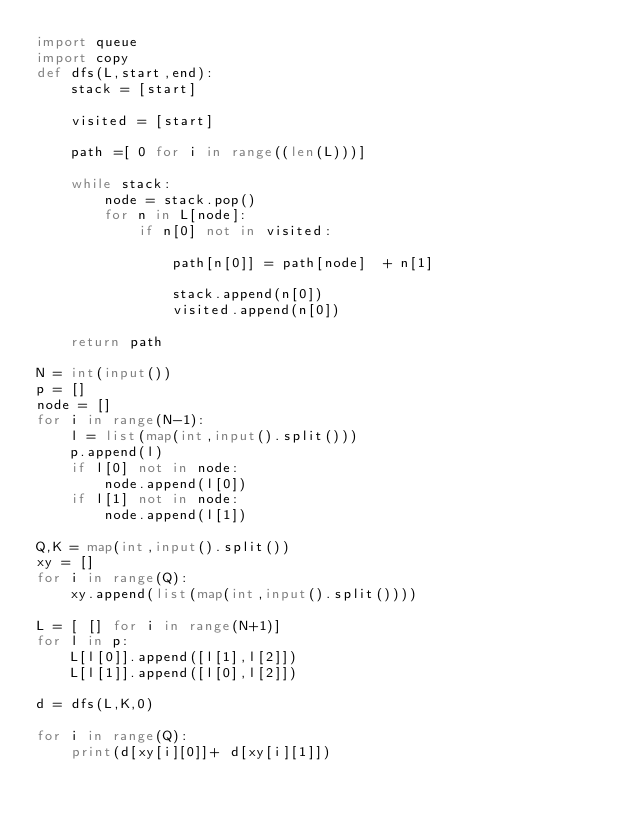Convert code to text. <code><loc_0><loc_0><loc_500><loc_500><_Python_>import queue
import copy
def dfs(L,start,end):
    stack = [start]

    visited = [start]

    path =[ 0 for i in range((len(L)))]

    while stack:
        node = stack.pop()
        for n in L[node]:
            if n[0] not in visited:

                path[n[0]] = path[node]  + n[1]

                stack.append(n[0])
                visited.append(n[0])

    return path

N = int(input())
p = []
node = []
for i in range(N-1):
    l = list(map(int,input().split()))
    p.append(l)
    if l[0] not in node:
        node.append(l[0])
    if l[1] not in node:
        node.append(l[1])

Q,K = map(int,input().split())
xy = []
for i in range(Q):
    xy.append(list(map(int,input().split())))

L = [ [] for i in range(N+1)]
for l in p:
    L[l[0]].append([l[1],l[2]])
    L[l[1]].append([l[0],l[2]])

d = dfs(L,K,0)

for i in range(Q):
    print(d[xy[i][0]]+ d[xy[i][1]])
</code> 